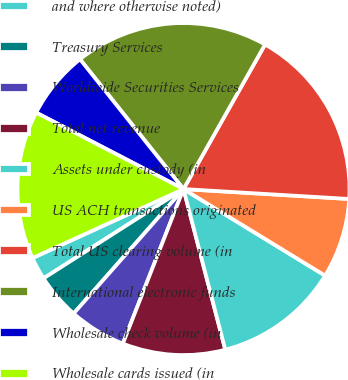Convert chart. <chart><loc_0><loc_0><loc_500><loc_500><pie_chart><fcel>and where otherwise noted)<fcel>Treasury Services<fcel>Worldwide Securities Services<fcel>Total net revenue<fcel>Assets under custody (in<fcel>US ACH transactions originated<fcel>Total US clearing volume (in<fcel>International electronic funds<fcel>Wholesale check volume (in<fcel>Wholesale cards issued (in<nl><fcel>2.22%<fcel>4.45%<fcel>5.56%<fcel>10.0%<fcel>12.22%<fcel>7.78%<fcel>17.78%<fcel>18.89%<fcel>6.67%<fcel>14.44%<nl></chart> 